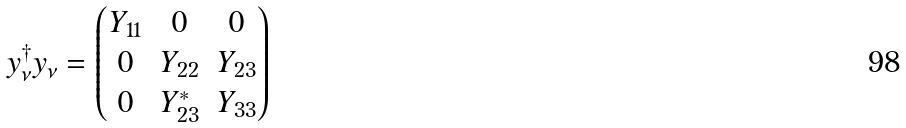Convert formula to latex. <formula><loc_0><loc_0><loc_500><loc_500>y _ { \nu } ^ { \dagger } y _ { \nu } = \begin{pmatrix} Y _ { 1 1 } & 0 & 0 \\ 0 & Y _ { 2 2 } & Y _ { 2 3 } \\ 0 & Y _ { 2 3 } ^ { * } & Y _ { 3 3 } \end{pmatrix}</formula> 